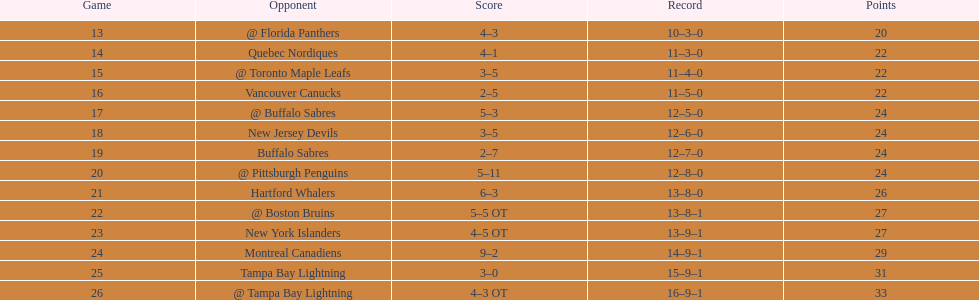Parse the full table. {'header': ['Game', 'Opponent', 'Score', 'Record', 'Points'], 'rows': [['13', '@ Florida Panthers', '4–3', '10–3–0', '20'], ['14', 'Quebec Nordiques', '4–1', '11–3–0', '22'], ['15', '@ Toronto Maple Leafs', '3–5', '11–4–0', '22'], ['16', 'Vancouver Canucks', '2–5', '11–5–0', '22'], ['17', '@ Buffalo Sabres', '5–3', '12–5–0', '24'], ['18', 'New Jersey Devils', '3–5', '12–6–0', '24'], ['19', 'Buffalo Sabres', '2–7', '12–7–0', '24'], ['20', '@ Pittsburgh Penguins', '5–11', '12–8–0', '24'], ['21', 'Hartford Whalers', '6–3', '13–8–0', '26'], ['22', '@ Boston Bruins', '5–5 OT', '13–8–1', '27'], ['23', 'New York Islanders', '4–5 OT', '13–9–1', '27'], ['24', 'Montreal Canadiens', '9–2', '14–9–1', '29'], ['25', 'Tampa Bay Lightning', '3–0', '15–9–1', '31'], ['26', '@ Tampa Bay Lightning', '4–3 OT', '16–9–1', '33']]} Did the tampa bay lightning have the least amount of wins? Yes. 